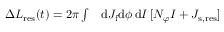Convert formula to latex. <formula><loc_0><loc_0><loc_500><loc_500>\begin{array} { r l } { \Delta L _ { r e s } ( t ) = 2 \pi \int } & d J _ { f } d \phi \, d I \, [ N _ { \varphi } I + J _ { s , r e s } ] } \end{array}</formula> 